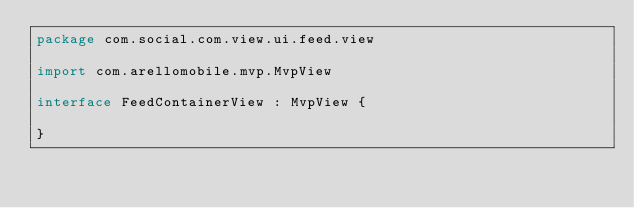<code> <loc_0><loc_0><loc_500><loc_500><_Kotlin_>package com.social.com.view.ui.feed.view

import com.arellomobile.mvp.MvpView

interface FeedContainerView : MvpView {

}
</code> 